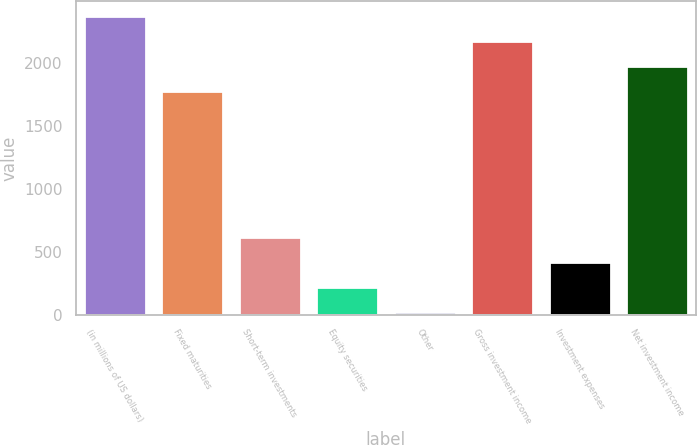<chart> <loc_0><loc_0><loc_500><loc_500><bar_chart><fcel>(in millions of US dollars)<fcel>Fixed maturities<fcel>Short-term investments<fcel>Equity securities<fcel>Other<fcel>Gross investment income<fcel>Investment expenses<fcel>Net investment income<nl><fcel>2367.6<fcel>1773<fcel>619.6<fcel>223.2<fcel>25<fcel>2169.4<fcel>421.4<fcel>1971.2<nl></chart> 